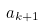Convert formula to latex. <formula><loc_0><loc_0><loc_500><loc_500>a _ { k + 1 }</formula> 